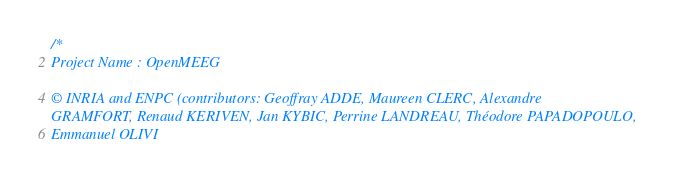<code> <loc_0><loc_0><loc_500><loc_500><_C++_>/*
Project Name : OpenMEEG

© INRIA and ENPC (contributors: Geoffray ADDE, Maureen CLERC, Alexandre
GRAMFORT, Renaud KERIVEN, Jan KYBIC, Perrine LANDREAU, Théodore PAPADOPOULO,
Emmanuel OLIVI</code> 